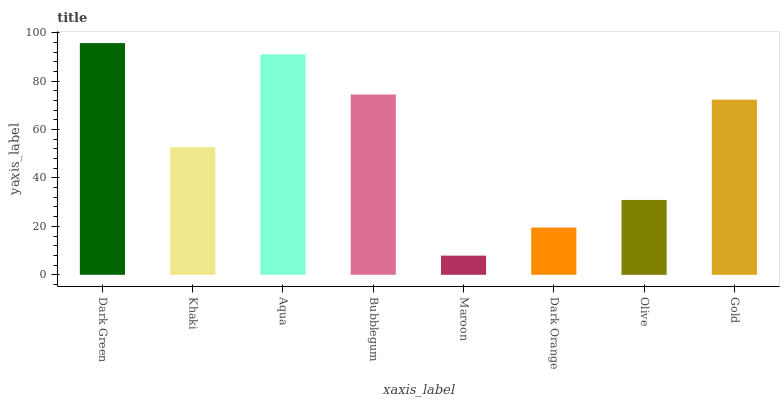Is Maroon the minimum?
Answer yes or no. Yes. Is Dark Green the maximum?
Answer yes or no. Yes. Is Khaki the minimum?
Answer yes or no. No. Is Khaki the maximum?
Answer yes or no. No. Is Dark Green greater than Khaki?
Answer yes or no. Yes. Is Khaki less than Dark Green?
Answer yes or no. Yes. Is Khaki greater than Dark Green?
Answer yes or no. No. Is Dark Green less than Khaki?
Answer yes or no. No. Is Gold the high median?
Answer yes or no. Yes. Is Khaki the low median?
Answer yes or no. Yes. Is Dark Green the high median?
Answer yes or no. No. Is Olive the low median?
Answer yes or no. No. 